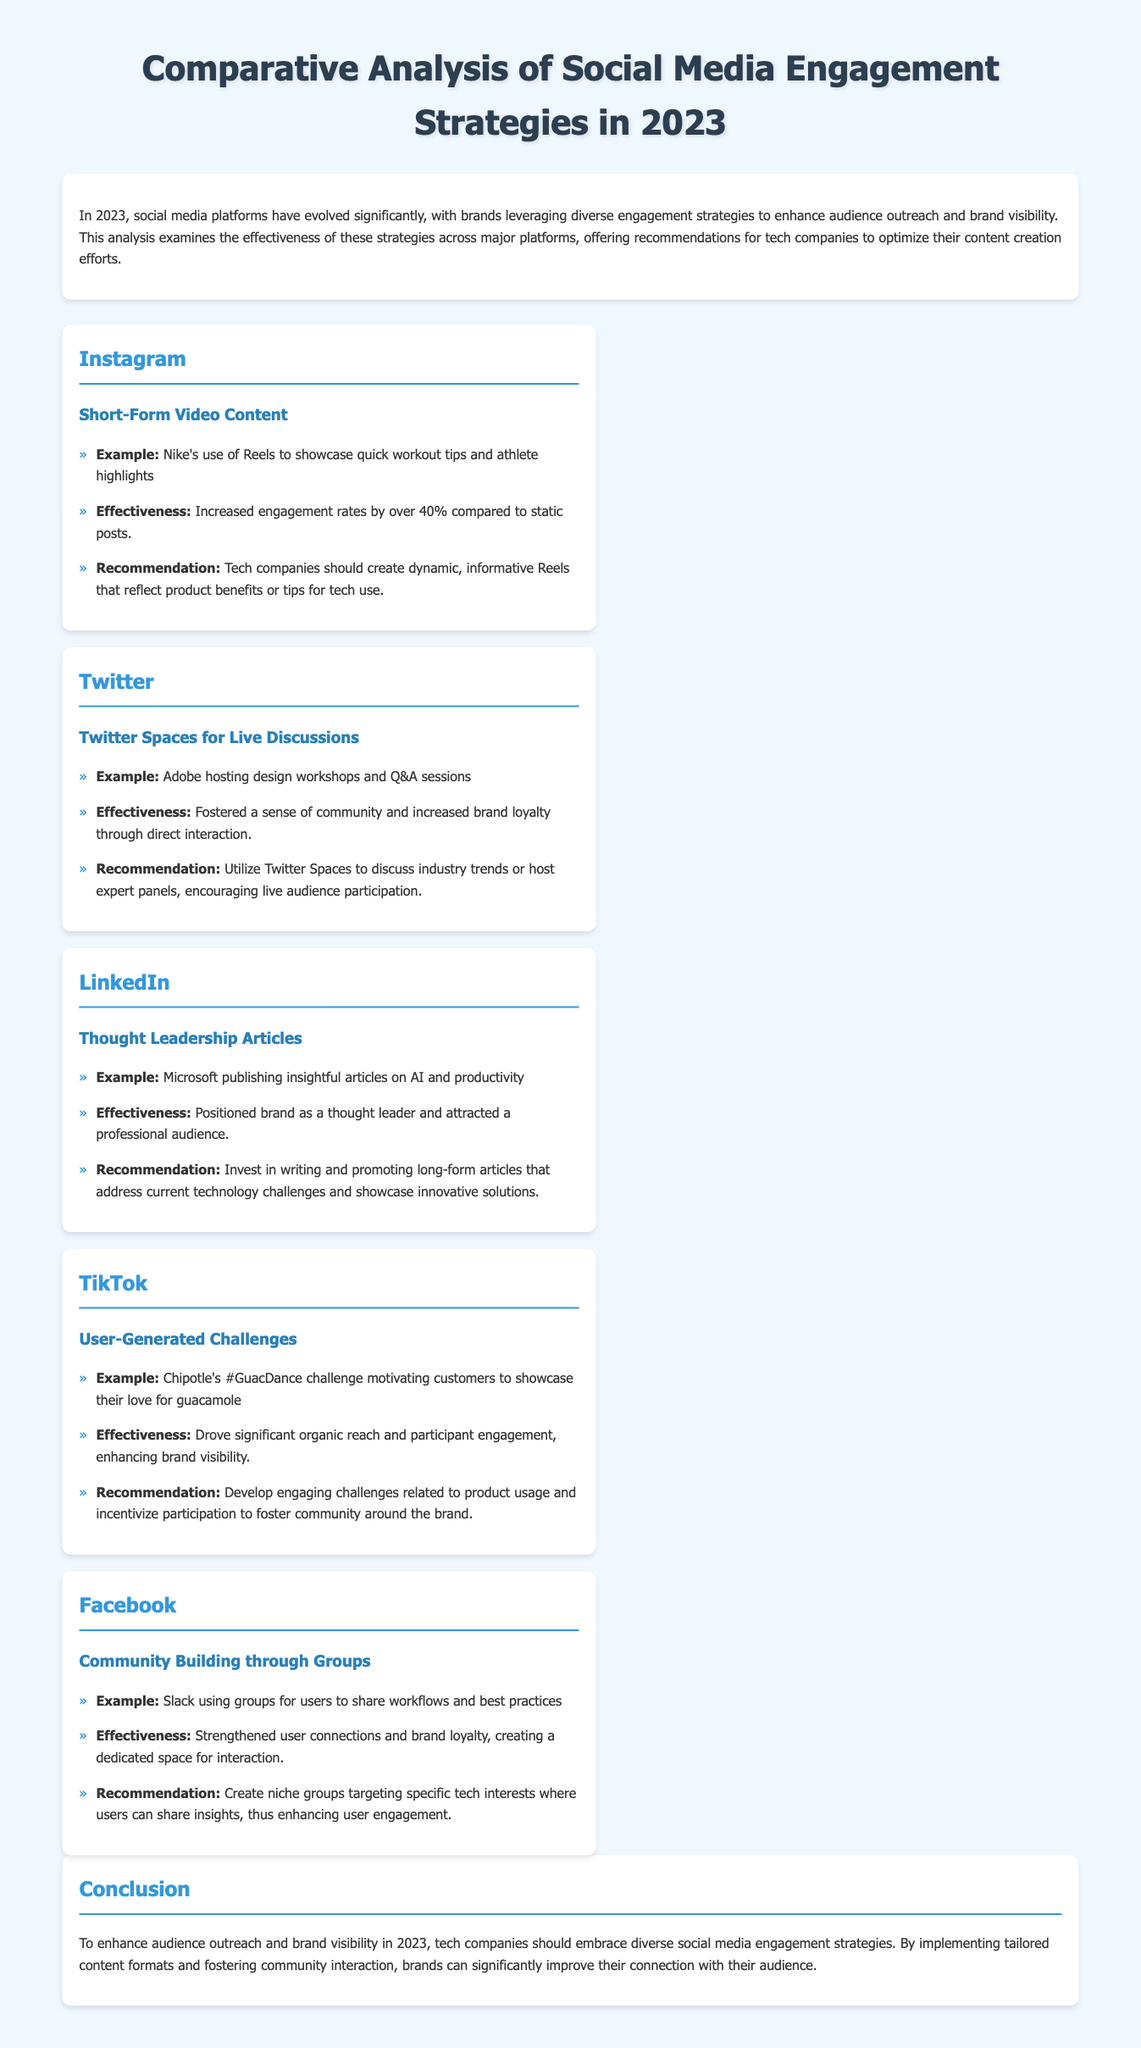What strategy did Nike use on Instagram? Nike used Reels to showcase quick workout tips and athlete highlights on Instagram.
Answer: Reels What was the effectiveness of short-form video content on Instagram? The increased engagement rates by over 40% compared to static posts.
Answer: Over 40% What type of content did Microsoft publish on LinkedIn? Microsoft published insightful articles on AI and productivity.
Answer: Thought Leadership Articles Which social media platform emphasizes community building through groups? Facebook emphasizes community building through groups.
Answer: Facebook What is the recommendation for companies using Twitter Spaces? Utilize Twitter Spaces to discuss industry trends or host expert panels.
Answer: Expert panels What was Chipotle's user-generated challenge on TikTok? Chipotle's challenge was the #GuacDance challenge.
Answer: #GuacDance How did Adobe engage their audience on Twitter? Adobe hosted design workshops and Q&A sessions.
Answer: Design workshops What should tech companies create for Instagram according to the document? Tech companies should create dynamic, informative Reels.
Answer: Dynamic, informative Reels What is the benefit of thoughtful leadership articles mentioned in the document? It positioned the brand as a thought leader and attracted a professional audience.
Answer: Thought leader 